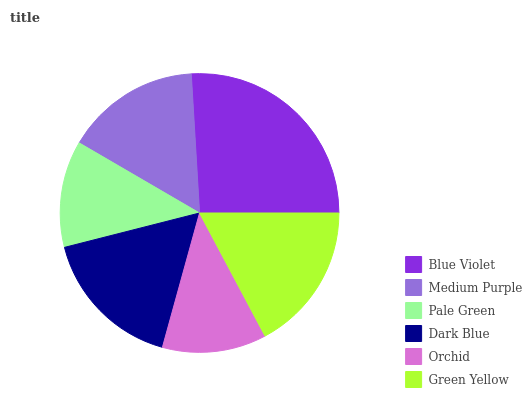Is Orchid the minimum?
Answer yes or no. Yes. Is Blue Violet the maximum?
Answer yes or no. Yes. Is Medium Purple the minimum?
Answer yes or no. No. Is Medium Purple the maximum?
Answer yes or no. No. Is Blue Violet greater than Medium Purple?
Answer yes or no. Yes. Is Medium Purple less than Blue Violet?
Answer yes or no. Yes. Is Medium Purple greater than Blue Violet?
Answer yes or no. No. Is Blue Violet less than Medium Purple?
Answer yes or no. No. Is Dark Blue the high median?
Answer yes or no. Yes. Is Medium Purple the low median?
Answer yes or no. Yes. Is Pale Green the high median?
Answer yes or no. No. Is Pale Green the low median?
Answer yes or no. No. 